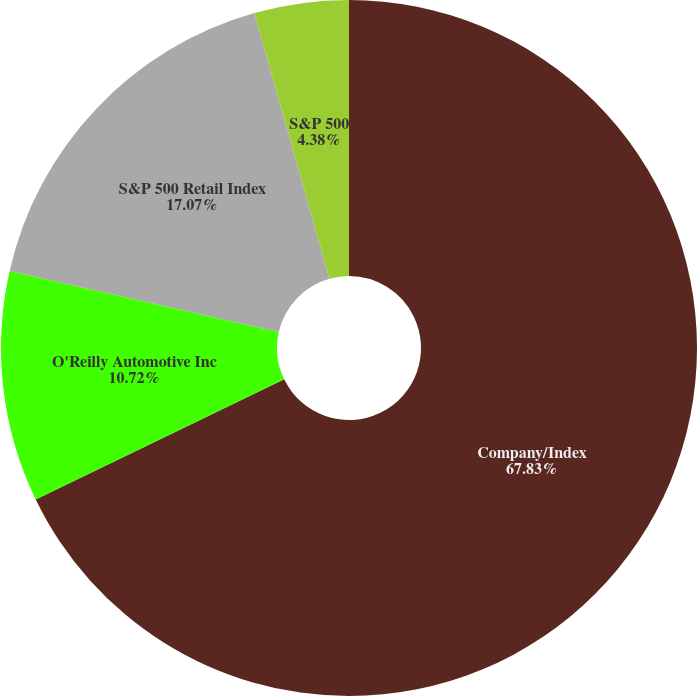Convert chart to OTSL. <chart><loc_0><loc_0><loc_500><loc_500><pie_chart><fcel>Company/Index<fcel>O'Reilly Automotive Inc<fcel>S&P 500 Retail Index<fcel>S&P 500<nl><fcel>67.83%<fcel>10.72%<fcel>17.07%<fcel>4.38%<nl></chart> 